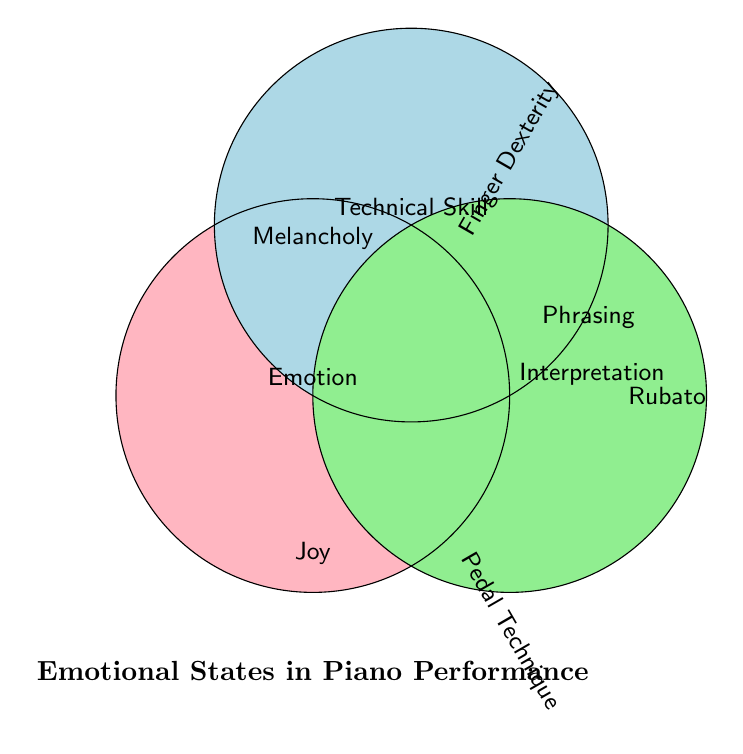What are the three main categories represented in the Venn Diagram? The Venn Diagram has three circles, each labeled with a category: "Emotion," "Technical Skill," and "Interpretation."
Answer: Emotion, Technical Skill, Interpretation Which emotion is positioned at the bottom of the diagram? The text at the bottom of the Venn Diagram indicates "Joy" as an emotion.
Answer: Joy What technical skill is associated with "Melancholy"? "Melancholy" is in the area overlapping with the "Technical Skill" circle, labeled closest to "Dynamic Control."
Answer: Dynamic Control Which interpretation skill is associated with "Passion"? "Passion" is located where the "Interpretation" circle is, linked with "Rubato."
Answer: Rubato Identify an emotion that overlaps with "Technical Skill" and "Interpretation." By observing the overlapping areas, the emotion that overlaps with both "Technical Skill" and "Interpretation" is "Passion."
Answer: Passion What skill is associated with both "Joy" and "Technical Skill"? The intersection of "Joy" and "Technical Skill" shows "Finger Dexterity."
Answer: Finger Dexterity Compare the positioning of "Phrasing" and "Rubato." Where are they located? "Phrasing" is within the overlap area of "Interpretation" and a broader range, while "Rubato" is exclusively in the "Interpretation" circle.
Answer: Phrasing is more central; Rubato is to the right Which emotion is closest to the title "Emotional States in Piano Performance"? The emotion placed nearest the title at the bottom of the figure is "Joy."
Answer: Joy 